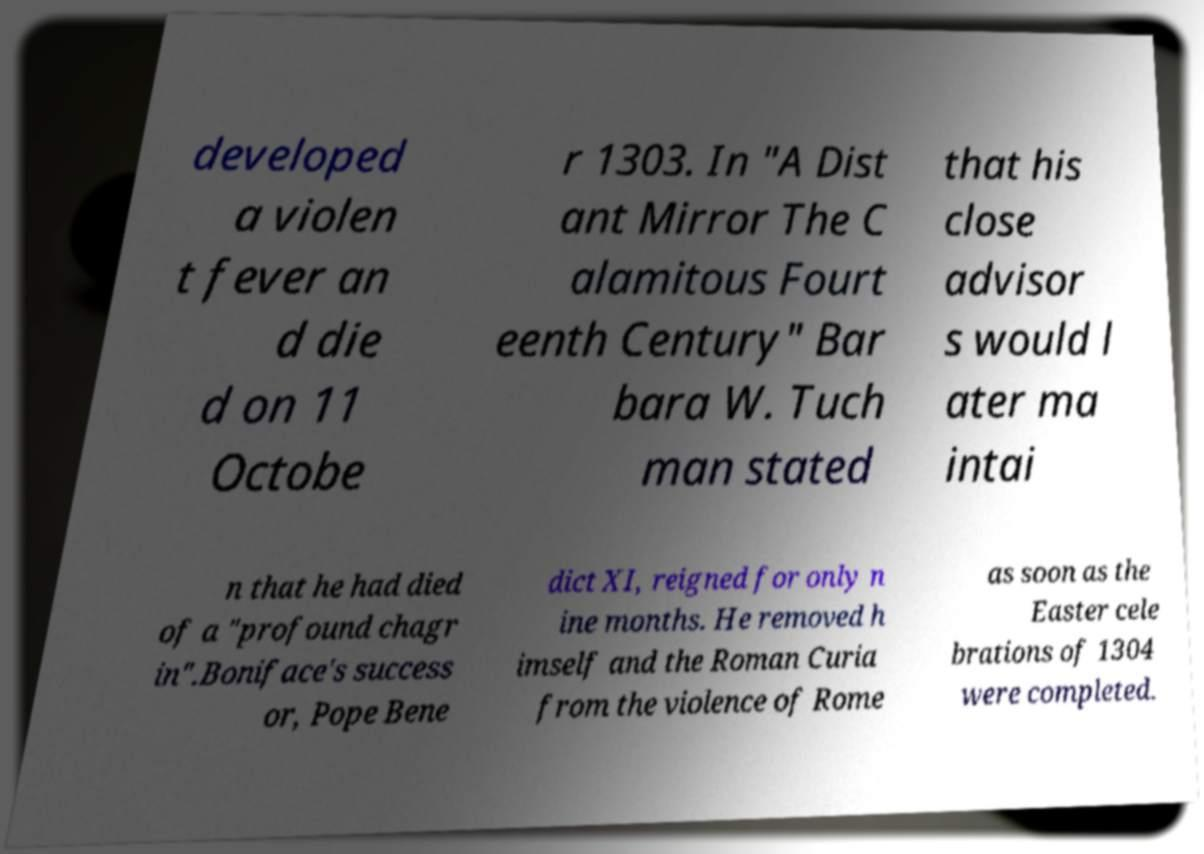Please identify and transcribe the text found in this image. developed a violen t fever an d die d on 11 Octobe r 1303. In "A Dist ant Mirror The C alamitous Fourt eenth Century" Bar bara W. Tuch man stated that his close advisor s would l ater ma intai n that he had died of a "profound chagr in".Boniface's success or, Pope Bene dict XI, reigned for only n ine months. He removed h imself and the Roman Curia from the violence of Rome as soon as the Easter cele brations of 1304 were completed. 